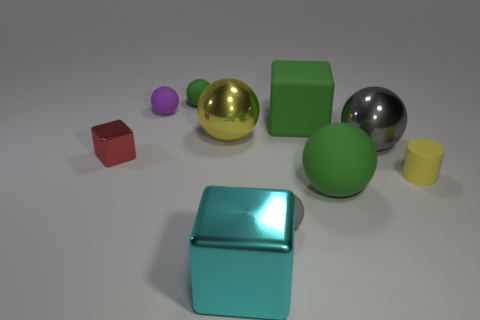How many gray spheres must be subtracted to get 1 gray spheres? 1 Subtract all tiny gray balls. How many balls are left? 5 Subtract all yellow balls. How many balls are left? 5 Subtract all brown balls. Subtract all gray cylinders. How many balls are left? 6 Subtract all spheres. How many objects are left? 4 Subtract all tiny red metallic things. Subtract all big yellow metal objects. How many objects are left? 8 Add 2 green balls. How many green balls are left? 4 Add 7 blue blocks. How many blue blocks exist? 7 Subtract 1 green blocks. How many objects are left? 9 